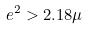Convert formula to latex. <formula><loc_0><loc_0><loc_500><loc_500>e ^ { 2 } > 2 . 1 8 \mu</formula> 